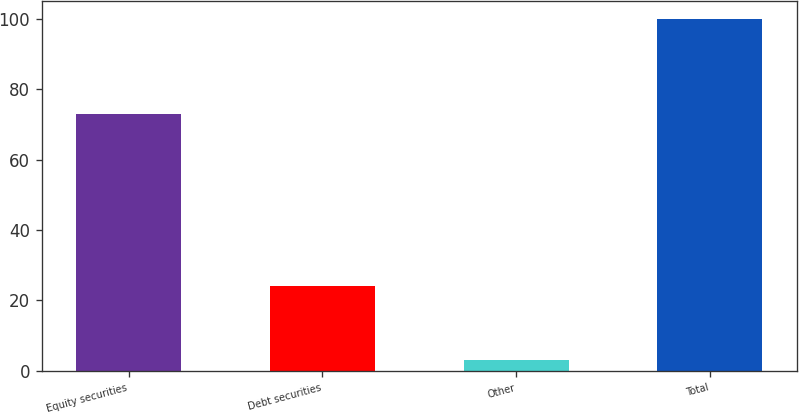<chart> <loc_0><loc_0><loc_500><loc_500><bar_chart><fcel>Equity securities<fcel>Debt securities<fcel>Other<fcel>Total<nl><fcel>73<fcel>24<fcel>3<fcel>100<nl></chart> 